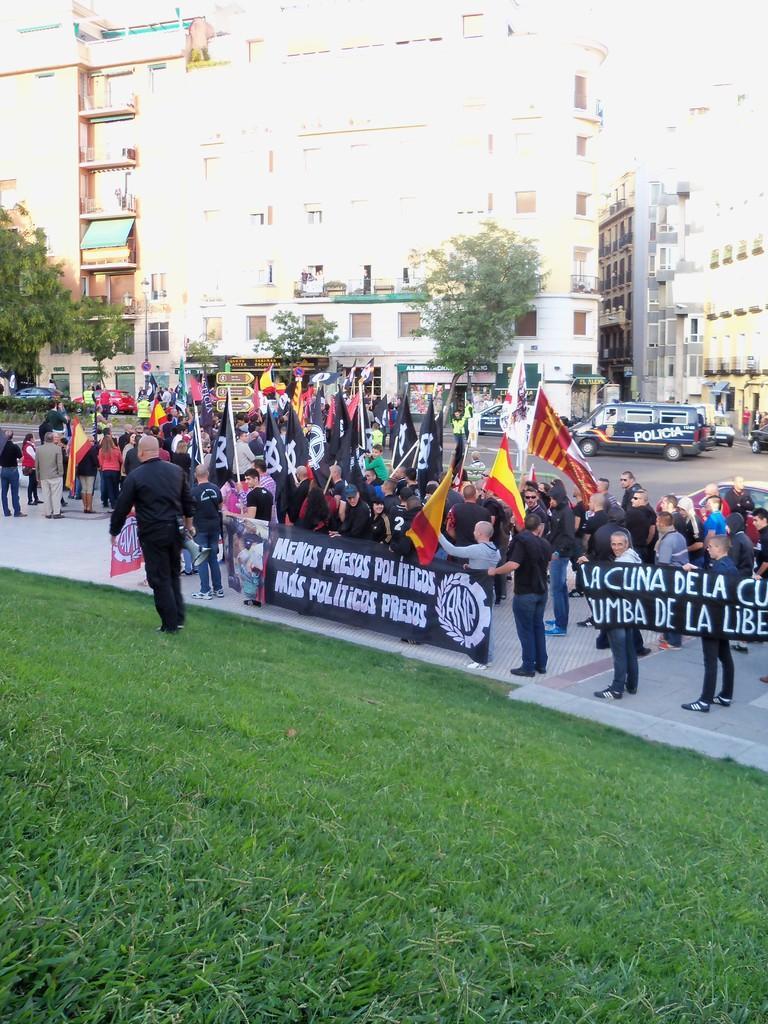Please provide a concise description of this image. In this image we can see there are people standing on the road and holding banners and flags. And there are vehicles on the road. And we can see there are buildings, boards, trees and grass. 